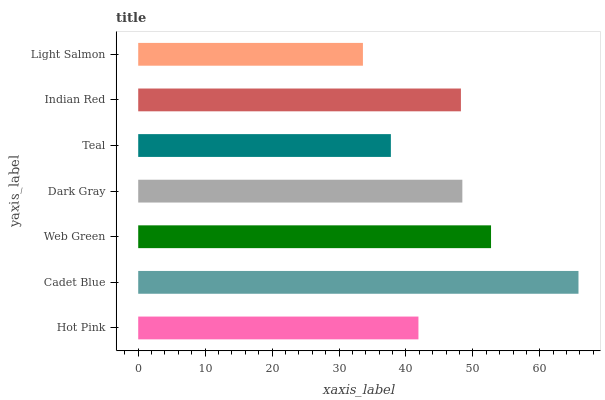Is Light Salmon the minimum?
Answer yes or no. Yes. Is Cadet Blue the maximum?
Answer yes or no. Yes. Is Web Green the minimum?
Answer yes or no. No. Is Web Green the maximum?
Answer yes or no. No. Is Cadet Blue greater than Web Green?
Answer yes or no. Yes. Is Web Green less than Cadet Blue?
Answer yes or no. Yes. Is Web Green greater than Cadet Blue?
Answer yes or no. No. Is Cadet Blue less than Web Green?
Answer yes or no. No. Is Indian Red the high median?
Answer yes or no. Yes. Is Indian Red the low median?
Answer yes or no. Yes. Is Hot Pink the high median?
Answer yes or no. No. Is Dark Gray the low median?
Answer yes or no. No. 